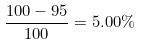Convert formula to latex. <formula><loc_0><loc_0><loc_500><loc_500>\frac { 1 0 0 - 9 5 } { 1 0 0 } = 5 . 0 0 \%</formula> 